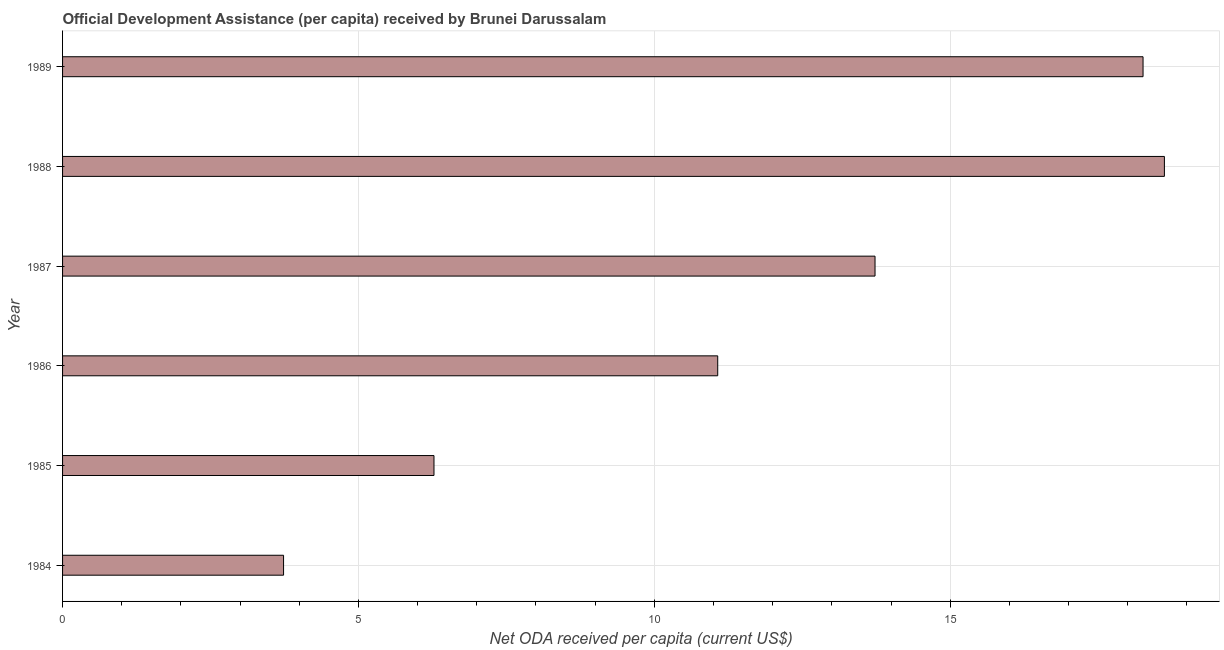Does the graph contain grids?
Your answer should be very brief. Yes. What is the title of the graph?
Ensure brevity in your answer.  Official Development Assistance (per capita) received by Brunei Darussalam. What is the label or title of the X-axis?
Give a very brief answer. Net ODA received per capita (current US$). What is the net oda received per capita in 1989?
Your answer should be compact. 18.26. Across all years, what is the maximum net oda received per capita?
Give a very brief answer. 18.62. Across all years, what is the minimum net oda received per capita?
Keep it short and to the point. 3.73. In which year was the net oda received per capita maximum?
Ensure brevity in your answer.  1988. In which year was the net oda received per capita minimum?
Your answer should be very brief. 1984. What is the sum of the net oda received per capita?
Offer a terse response. 71.69. What is the difference between the net oda received per capita in 1984 and 1987?
Give a very brief answer. -9.99. What is the average net oda received per capita per year?
Your response must be concise. 11.95. What is the median net oda received per capita?
Give a very brief answer. 12.4. What is the ratio of the net oda received per capita in 1986 to that in 1987?
Provide a short and direct response. 0.81. Is the net oda received per capita in 1984 less than that in 1988?
Make the answer very short. Yes. Is the difference between the net oda received per capita in 1984 and 1986 greater than the difference between any two years?
Keep it short and to the point. No. What is the difference between the highest and the second highest net oda received per capita?
Your answer should be very brief. 0.36. What is the difference between the highest and the lowest net oda received per capita?
Offer a very short reply. 14.89. In how many years, is the net oda received per capita greater than the average net oda received per capita taken over all years?
Your answer should be compact. 3. What is the difference between two consecutive major ticks on the X-axis?
Provide a short and direct response. 5. Are the values on the major ticks of X-axis written in scientific E-notation?
Your answer should be very brief. No. What is the Net ODA received per capita (current US$) in 1984?
Keep it short and to the point. 3.73. What is the Net ODA received per capita (current US$) in 1985?
Your answer should be compact. 6.28. What is the Net ODA received per capita (current US$) in 1986?
Offer a very short reply. 11.07. What is the Net ODA received per capita (current US$) of 1987?
Give a very brief answer. 13.73. What is the Net ODA received per capita (current US$) in 1988?
Your response must be concise. 18.62. What is the Net ODA received per capita (current US$) in 1989?
Provide a short and direct response. 18.26. What is the difference between the Net ODA received per capita (current US$) in 1984 and 1985?
Give a very brief answer. -2.54. What is the difference between the Net ODA received per capita (current US$) in 1984 and 1986?
Give a very brief answer. -7.34. What is the difference between the Net ODA received per capita (current US$) in 1984 and 1987?
Your answer should be compact. -10. What is the difference between the Net ODA received per capita (current US$) in 1984 and 1988?
Your response must be concise. -14.89. What is the difference between the Net ODA received per capita (current US$) in 1984 and 1989?
Offer a terse response. -14.52. What is the difference between the Net ODA received per capita (current US$) in 1985 and 1986?
Keep it short and to the point. -4.79. What is the difference between the Net ODA received per capita (current US$) in 1985 and 1987?
Provide a succinct answer. -7.45. What is the difference between the Net ODA received per capita (current US$) in 1985 and 1988?
Give a very brief answer. -12.34. What is the difference between the Net ODA received per capita (current US$) in 1985 and 1989?
Your answer should be very brief. -11.98. What is the difference between the Net ODA received per capita (current US$) in 1986 and 1987?
Offer a very short reply. -2.66. What is the difference between the Net ODA received per capita (current US$) in 1986 and 1988?
Make the answer very short. -7.55. What is the difference between the Net ODA received per capita (current US$) in 1986 and 1989?
Your answer should be very brief. -7.19. What is the difference between the Net ODA received per capita (current US$) in 1987 and 1988?
Keep it short and to the point. -4.89. What is the difference between the Net ODA received per capita (current US$) in 1987 and 1989?
Your response must be concise. -4.53. What is the difference between the Net ODA received per capita (current US$) in 1988 and 1989?
Make the answer very short. 0.36. What is the ratio of the Net ODA received per capita (current US$) in 1984 to that in 1985?
Provide a short and direct response. 0.59. What is the ratio of the Net ODA received per capita (current US$) in 1984 to that in 1986?
Keep it short and to the point. 0.34. What is the ratio of the Net ODA received per capita (current US$) in 1984 to that in 1987?
Provide a succinct answer. 0.27. What is the ratio of the Net ODA received per capita (current US$) in 1984 to that in 1988?
Make the answer very short. 0.2. What is the ratio of the Net ODA received per capita (current US$) in 1984 to that in 1989?
Give a very brief answer. 0.2. What is the ratio of the Net ODA received per capita (current US$) in 1985 to that in 1986?
Offer a terse response. 0.57. What is the ratio of the Net ODA received per capita (current US$) in 1985 to that in 1987?
Your response must be concise. 0.46. What is the ratio of the Net ODA received per capita (current US$) in 1985 to that in 1988?
Give a very brief answer. 0.34. What is the ratio of the Net ODA received per capita (current US$) in 1985 to that in 1989?
Offer a very short reply. 0.34. What is the ratio of the Net ODA received per capita (current US$) in 1986 to that in 1987?
Make the answer very short. 0.81. What is the ratio of the Net ODA received per capita (current US$) in 1986 to that in 1988?
Make the answer very short. 0.59. What is the ratio of the Net ODA received per capita (current US$) in 1986 to that in 1989?
Your response must be concise. 0.61. What is the ratio of the Net ODA received per capita (current US$) in 1987 to that in 1988?
Offer a very short reply. 0.74. What is the ratio of the Net ODA received per capita (current US$) in 1987 to that in 1989?
Offer a very short reply. 0.75. What is the ratio of the Net ODA received per capita (current US$) in 1988 to that in 1989?
Offer a very short reply. 1.02. 